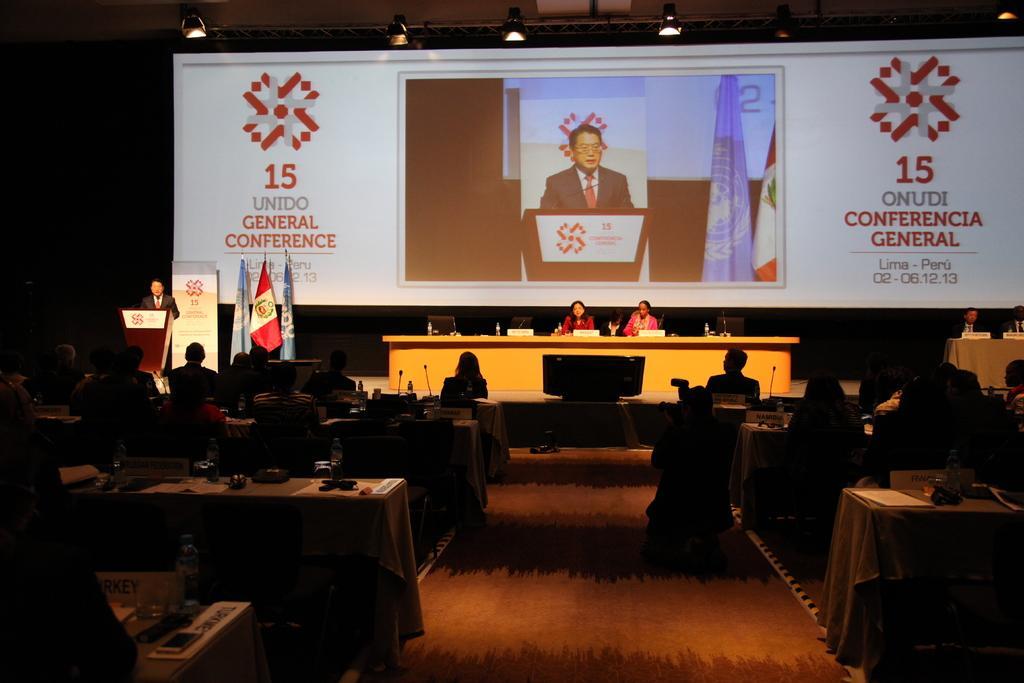Could you give a brief overview of what you see in this image? In this image i can see few people sitting, on table there is a micro phone in front of them at the back ground there is a podium and a screen and a flag. 